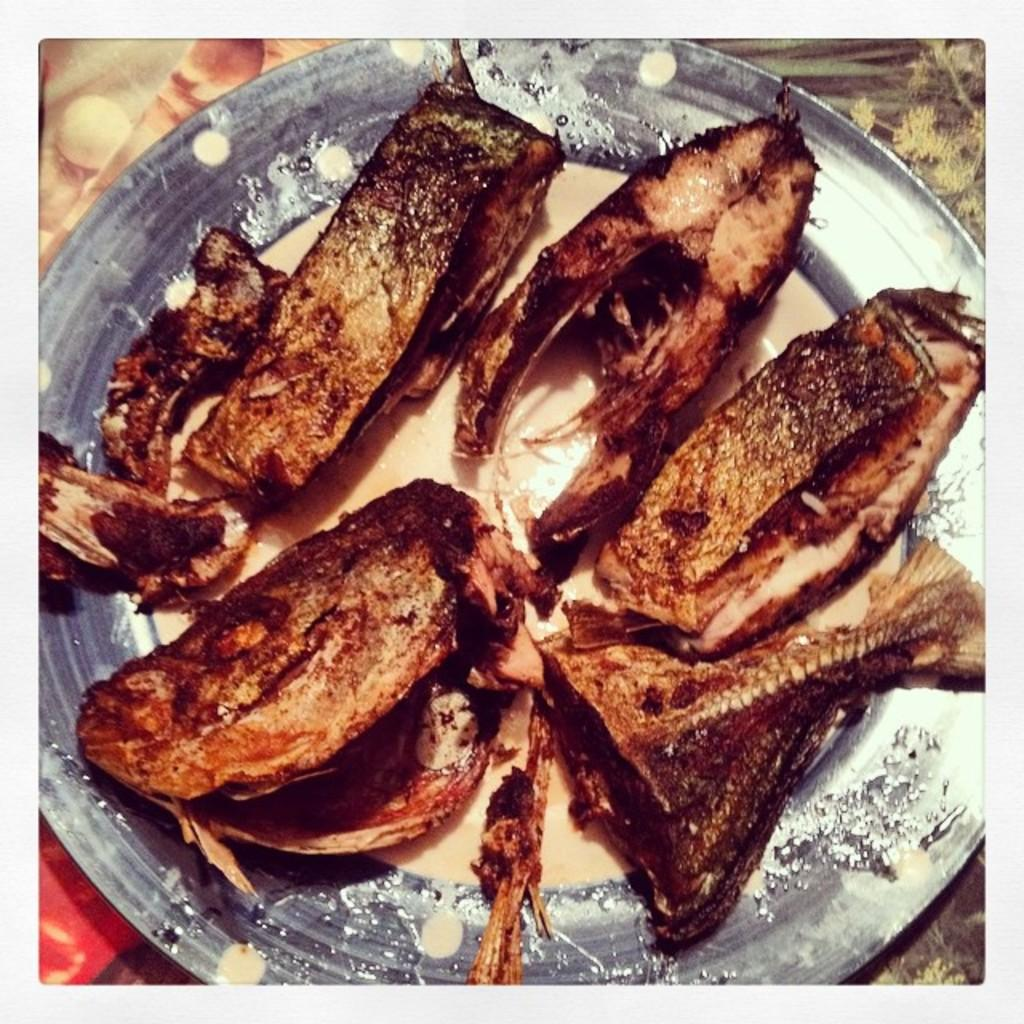What is on the plate that is visible in the image? There are pieces of fried fish on the plate. Where is the plate located in the image? The plate is on a surface in the image. What type of linen is draped over the fried fish in the image? There is no linen present in the image, and the fried fish is not covered by any fabric. 